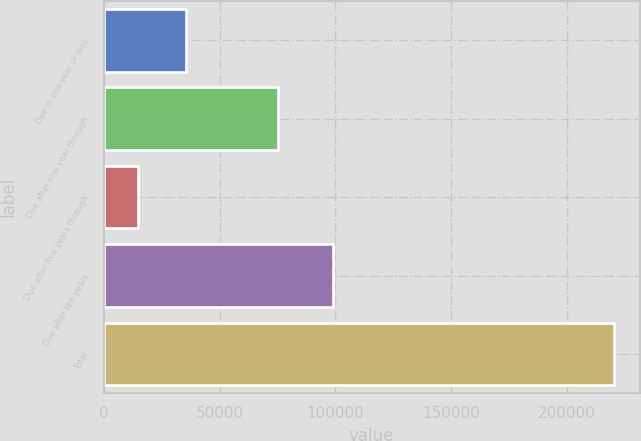Convert chart. <chart><loc_0><loc_0><loc_500><loc_500><bar_chart><fcel>Due in one year or less<fcel>Due after one year through<fcel>Due after five years through<fcel>Due after ten years<fcel>Total<nl><fcel>35382.8<fcel>75183<fcel>14821<fcel>98851<fcel>220439<nl></chart> 